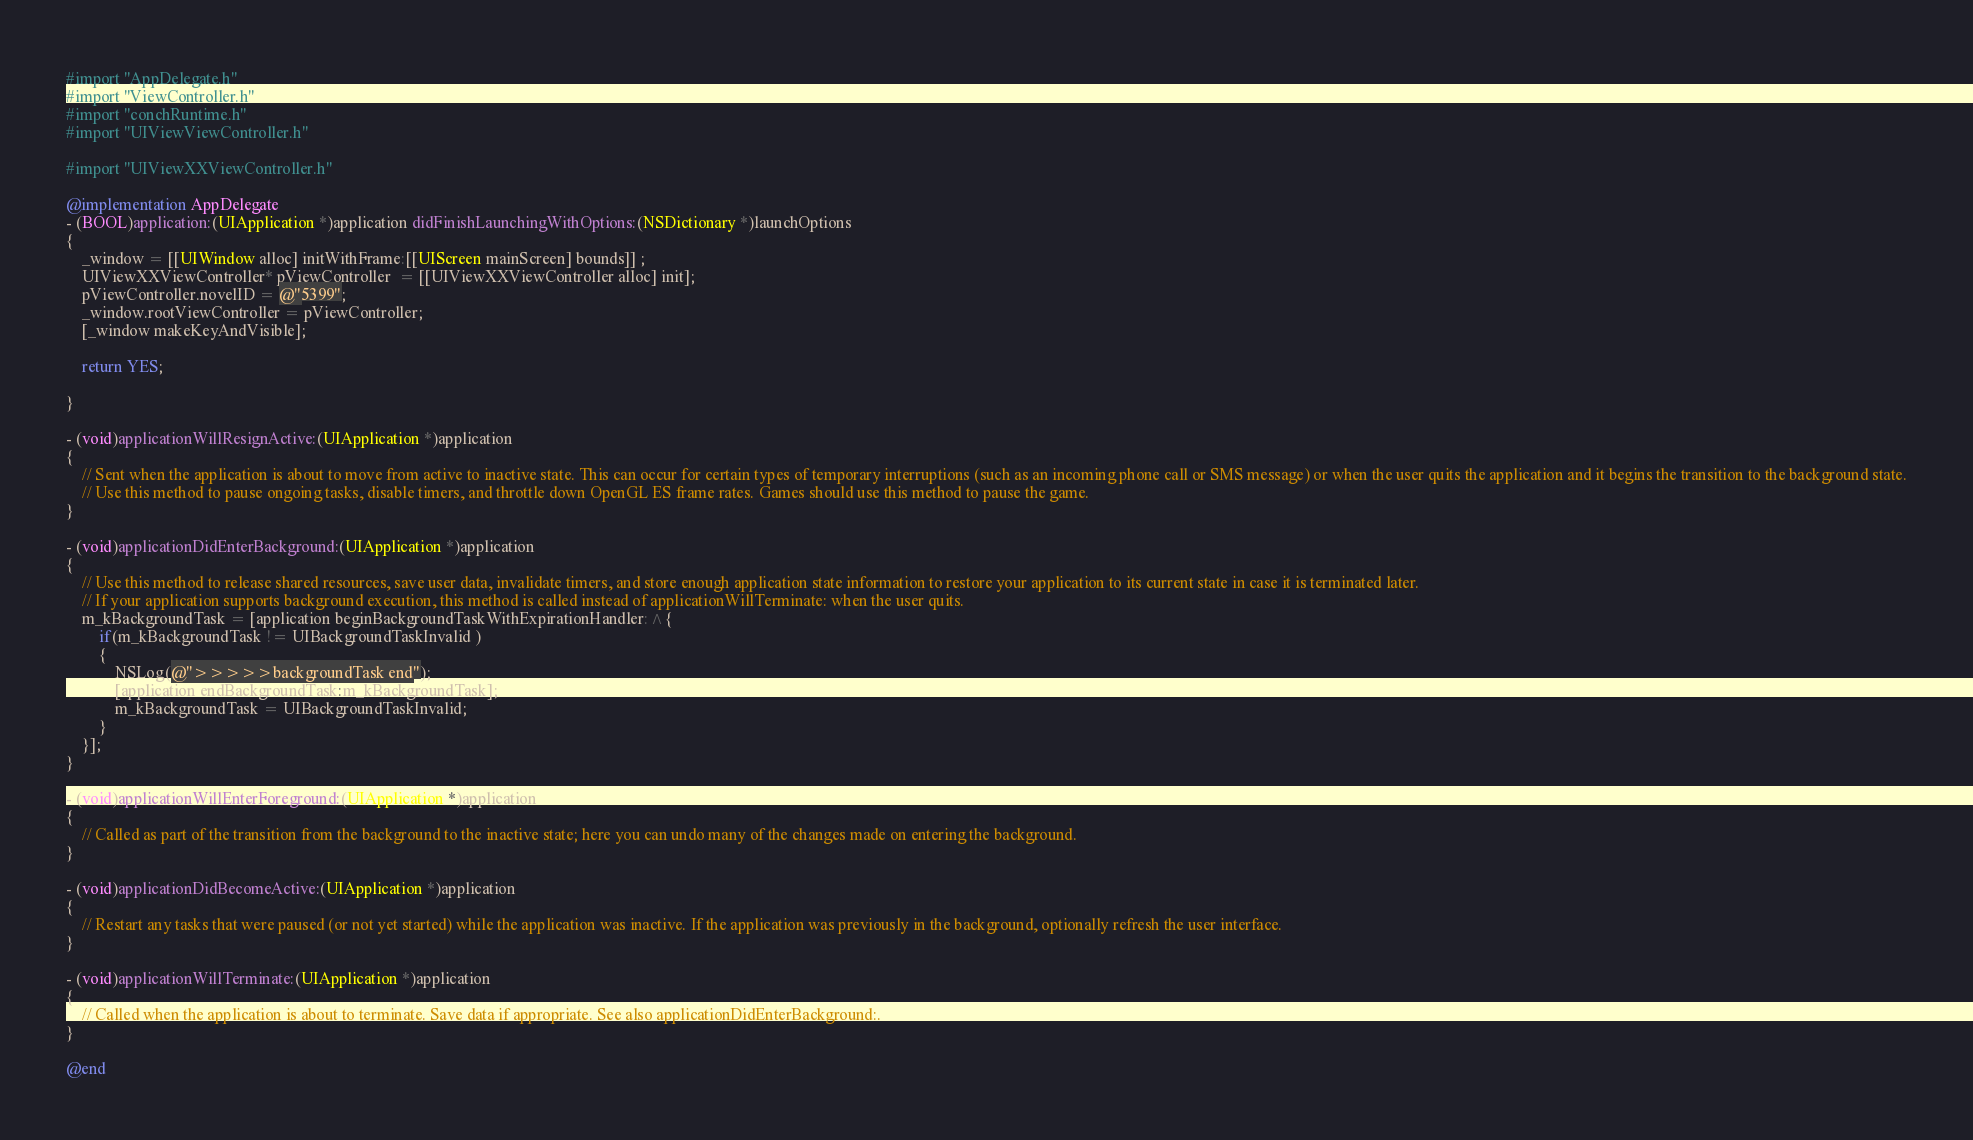Convert code to text. <code><loc_0><loc_0><loc_500><loc_500><_ObjectiveC_>#import "AppDelegate.h"
#import "ViewController.h"
#import "conchRuntime.h"
#import "UIViewViewController.h"

#import "UIViewXXViewController.h"

@implementation AppDelegate
- (BOOL)application:(UIApplication *)application didFinishLaunchingWithOptions:(NSDictionary *)launchOptions
{
    _window = [[UIWindow alloc] initWithFrame:[[UIScreen mainScreen] bounds]] ;
    UIViewXXViewController* pViewController  = [[UIViewXXViewController alloc] init];
    pViewController.novelID = @"5399";
    _window.rootViewController = pViewController;
    [_window makeKeyAndVisible];
    
    return YES;
    
}

- (void)applicationWillResignActive:(UIApplication *)application
{
    // Sent when the application is about to move from active to inactive state. This can occur for certain types of temporary interruptions (such as an incoming phone call or SMS message) or when the user quits the application and it begins the transition to the background state.
    // Use this method to pause ongoing tasks, disable timers, and throttle down OpenGL ES frame rates. Games should use this method to pause the game.
}

- (void)applicationDidEnterBackground:(UIApplication *)application
{
    // Use this method to release shared resources, save user data, invalidate timers, and store enough application state information to restore your application to its current state in case it is terminated later.
    // If your application supports background execution, this method is called instead of applicationWillTerminate: when the user quits.
    m_kBackgroundTask = [application beginBackgroundTaskWithExpirationHandler:^{
        if(m_kBackgroundTask != UIBackgroundTaskInvalid )
        {
            NSLog(@">>>>>backgroundTask end");
            [application endBackgroundTask:m_kBackgroundTask];
            m_kBackgroundTask = UIBackgroundTaskInvalid;
        }
    }];
}

- (void)applicationWillEnterForeground:(UIApplication *)application
{
    // Called as part of the transition from the background to the inactive state; here you can undo many of the changes made on entering the background.
}

- (void)applicationDidBecomeActive:(UIApplication *)application
{
    // Restart any tasks that were paused (or not yet started) while the application was inactive. If the application was previously in the background, optionally refresh the user interface.
}

- (void)applicationWillTerminate:(UIApplication *)application
{
    // Called when the application is about to terminate. Save data if appropriate. See also applicationDidEnterBackground:.
}

@end
</code> 